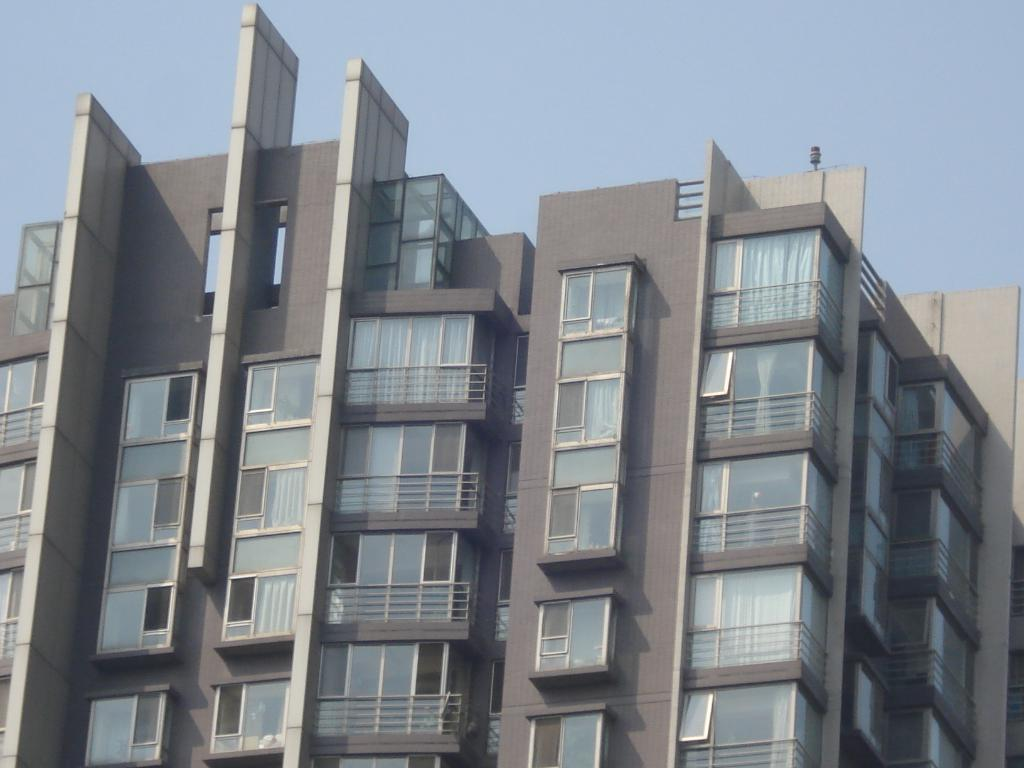What type of structures can be seen in the image? There are buildings in the image. What feature can be observed on the buildings? There are windows in the image. Are there any window treatments visible in the image? Yes, there are curtains in the image. What is visible in the background of the image? The sky is visible in the image. What role does the actor play in the destruction of the buildings in the image? There is no actor or destruction present in the image; it features buildings with windows and curtains, and the sky is visible in the background. 